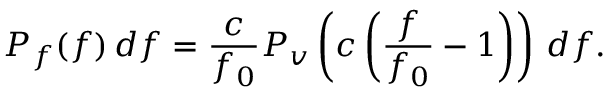<formula> <loc_0><loc_0><loc_500><loc_500>P _ { f } ( f ) \, d f = { \frac { c } { f _ { 0 } } } P _ { v } \left ( c \left ( { \frac { f } { f _ { 0 } } } - 1 \right ) \right ) \, d f .</formula> 